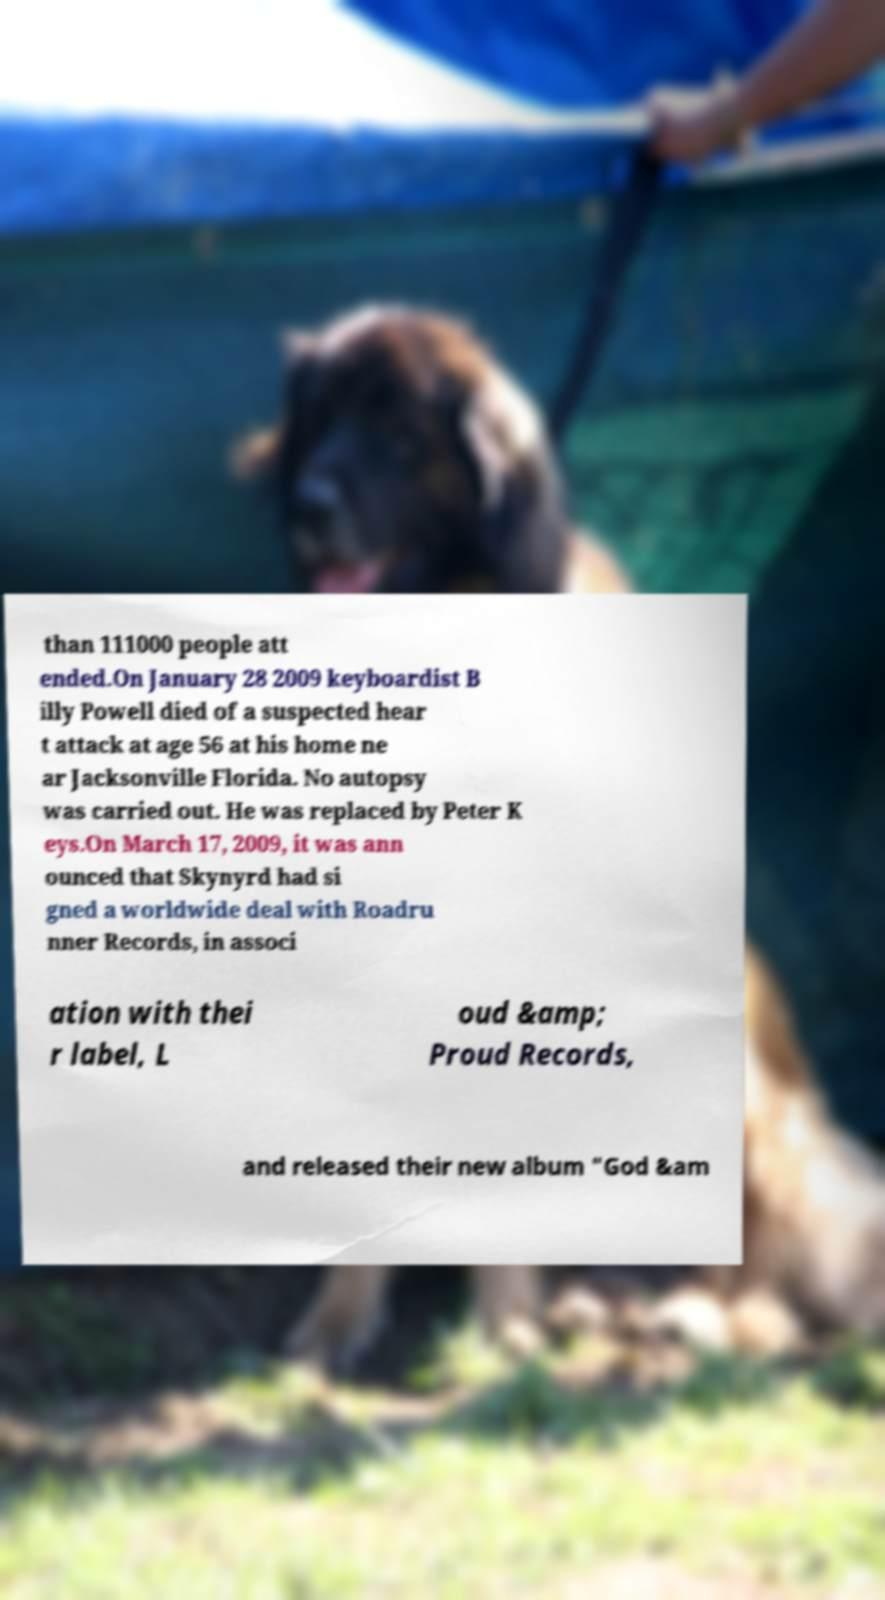Can you read and provide the text displayed in the image?This photo seems to have some interesting text. Can you extract and type it out for me? than 111000 people att ended.On January 28 2009 keyboardist B illy Powell died of a suspected hear t attack at age 56 at his home ne ar Jacksonville Florida. No autopsy was carried out. He was replaced by Peter K eys.On March 17, 2009, it was ann ounced that Skynyrd had si gned a worldwide deal with Roadru nner Records, in associ ation with thei r label, L oud &amp; Proud Records, and released their new album "God &am 